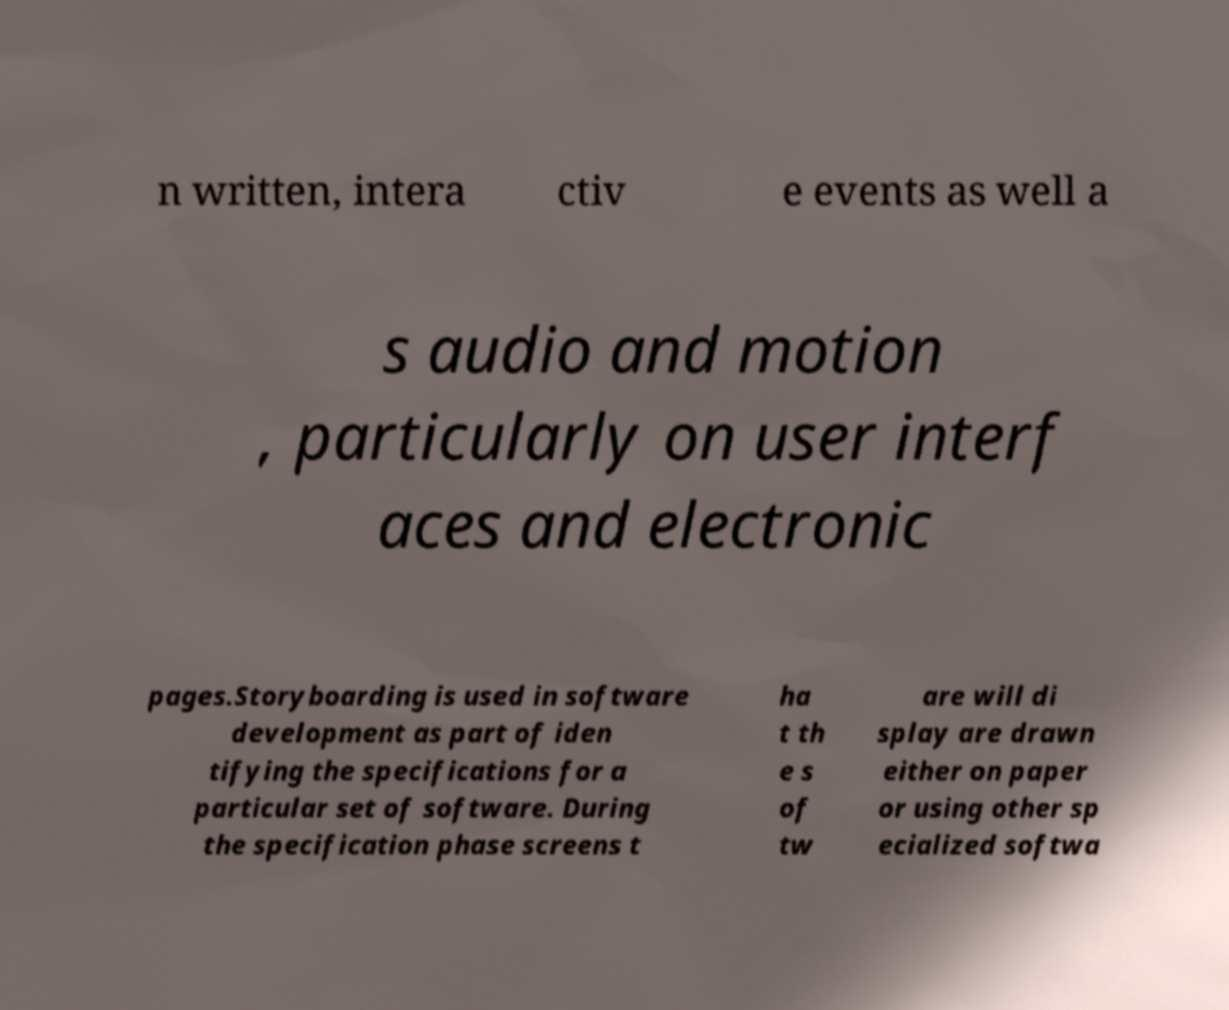Please identify and transcribe the text found in this image. n written, intera ctiv e events as well a s audio and motion , particularly on user interf aces and electronic pages.Storyboarding is used in software development as part of iden tifying the specifications for a particular set of software. During the specification phase screens t ha t th e s of tw are will di splay are drawn either on paper or using other sp ecialized softwa 